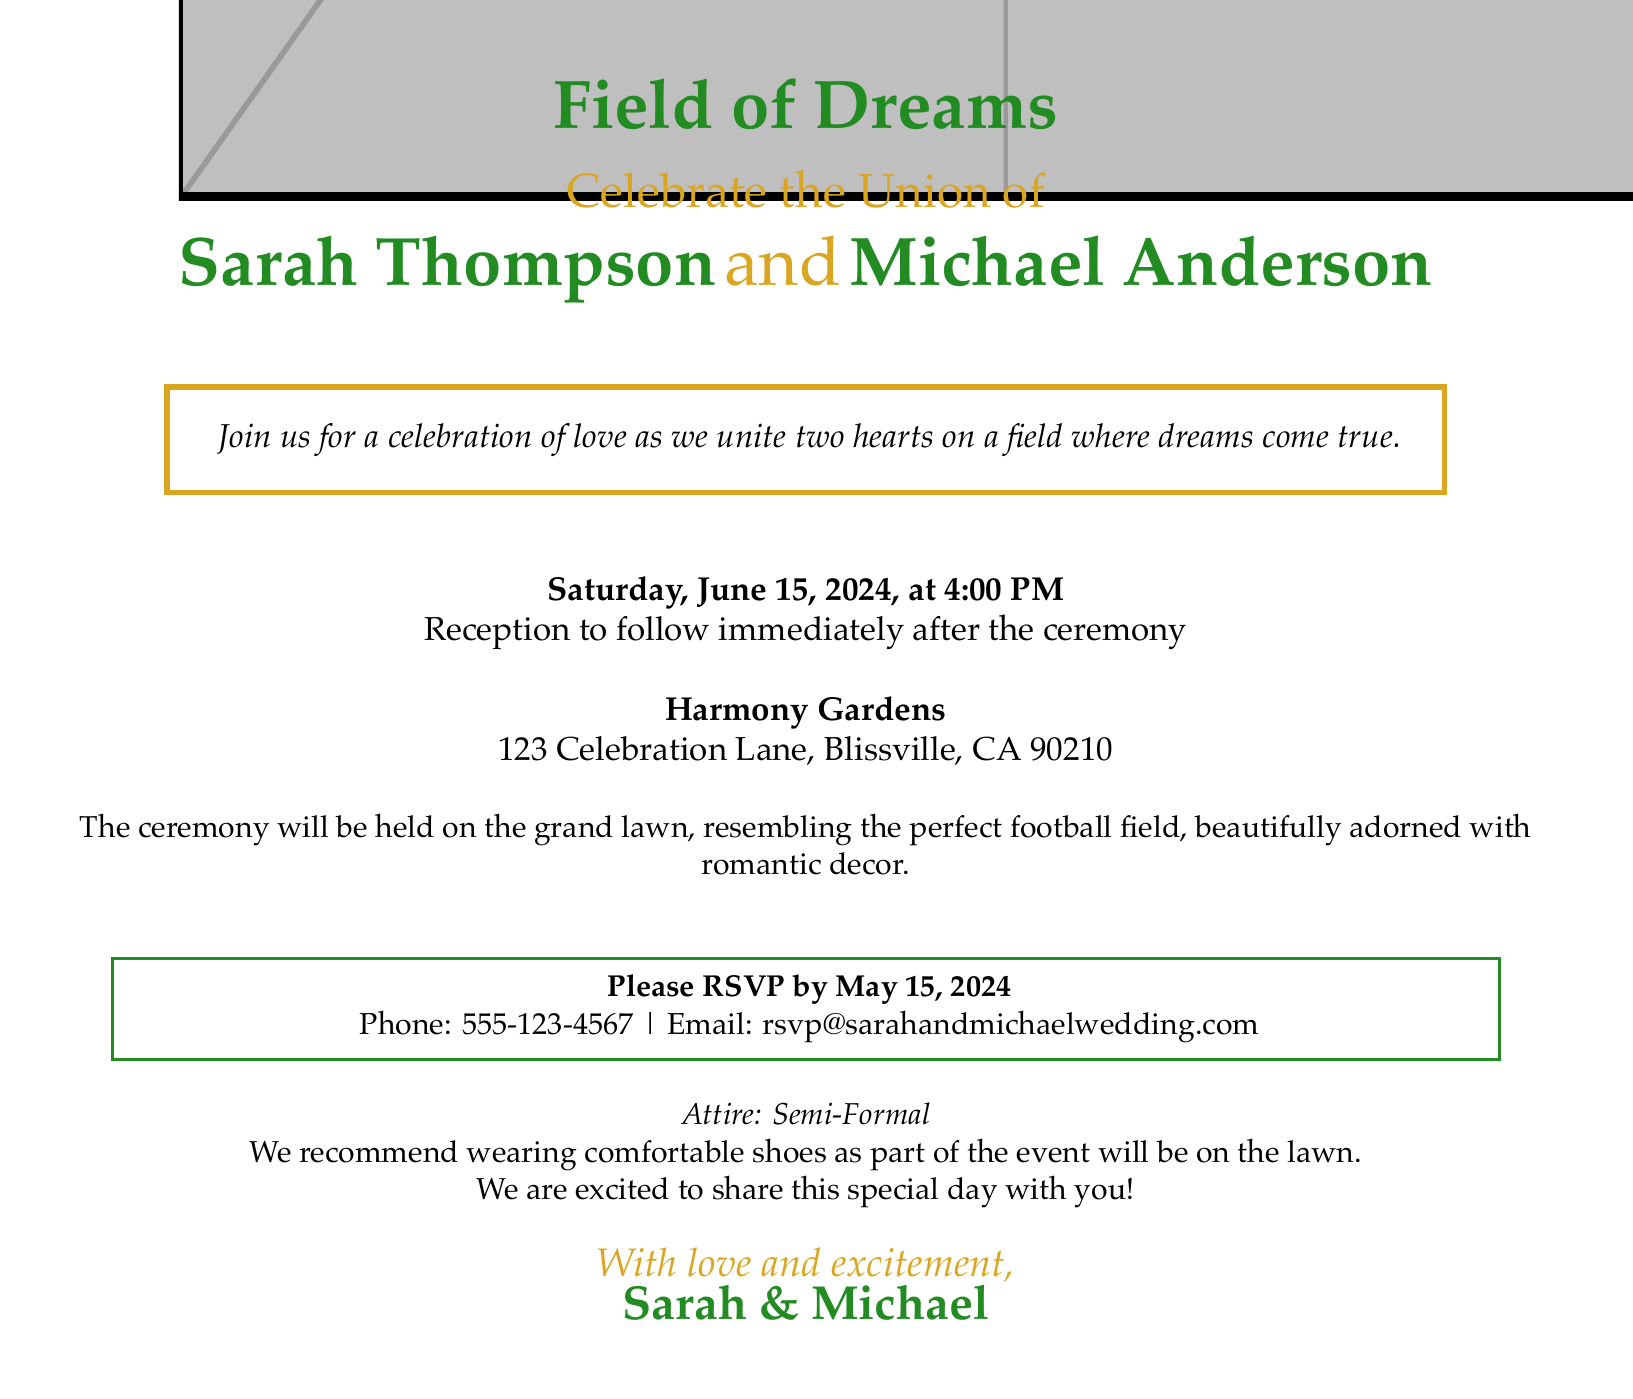What is the theme of the wedding invitation? The theme is expressed in the title of the invitation.
Answer: Field of Dreams Who are the couple getting married? The full names of the couple are clearly presented in the invitation.
Answer: Sarah Thompson and Michael Anderson What is the date of the wedding? The date is explicitly stated in the document.
Answer: Saturday, June 15, 2024 Where will the ceremony take place? The location is specified under the reception details.
Answer: Harmony Gardens What time is the wedding ceremony scheduled for? The time is mentioned in the document.
Answer: 4:00 PM What is requested from guests by May 15, 2024? The invitation makes a specific request to guests.
Answer: RSVP What attire is recommended for the event? Attire details are included towards the end of the invitation.
Answer: Semi-Formal What is specifically mentioned about the ceremony's location? A description of the ceremony's setting is provided in the details.
Answer: Resembles the perfect football field 